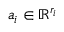<formula> <loc_0><loc_0><loc_500><loc_500>a _ { i } \in \mathbb { R } ^ { r _ { i } }</formula> 